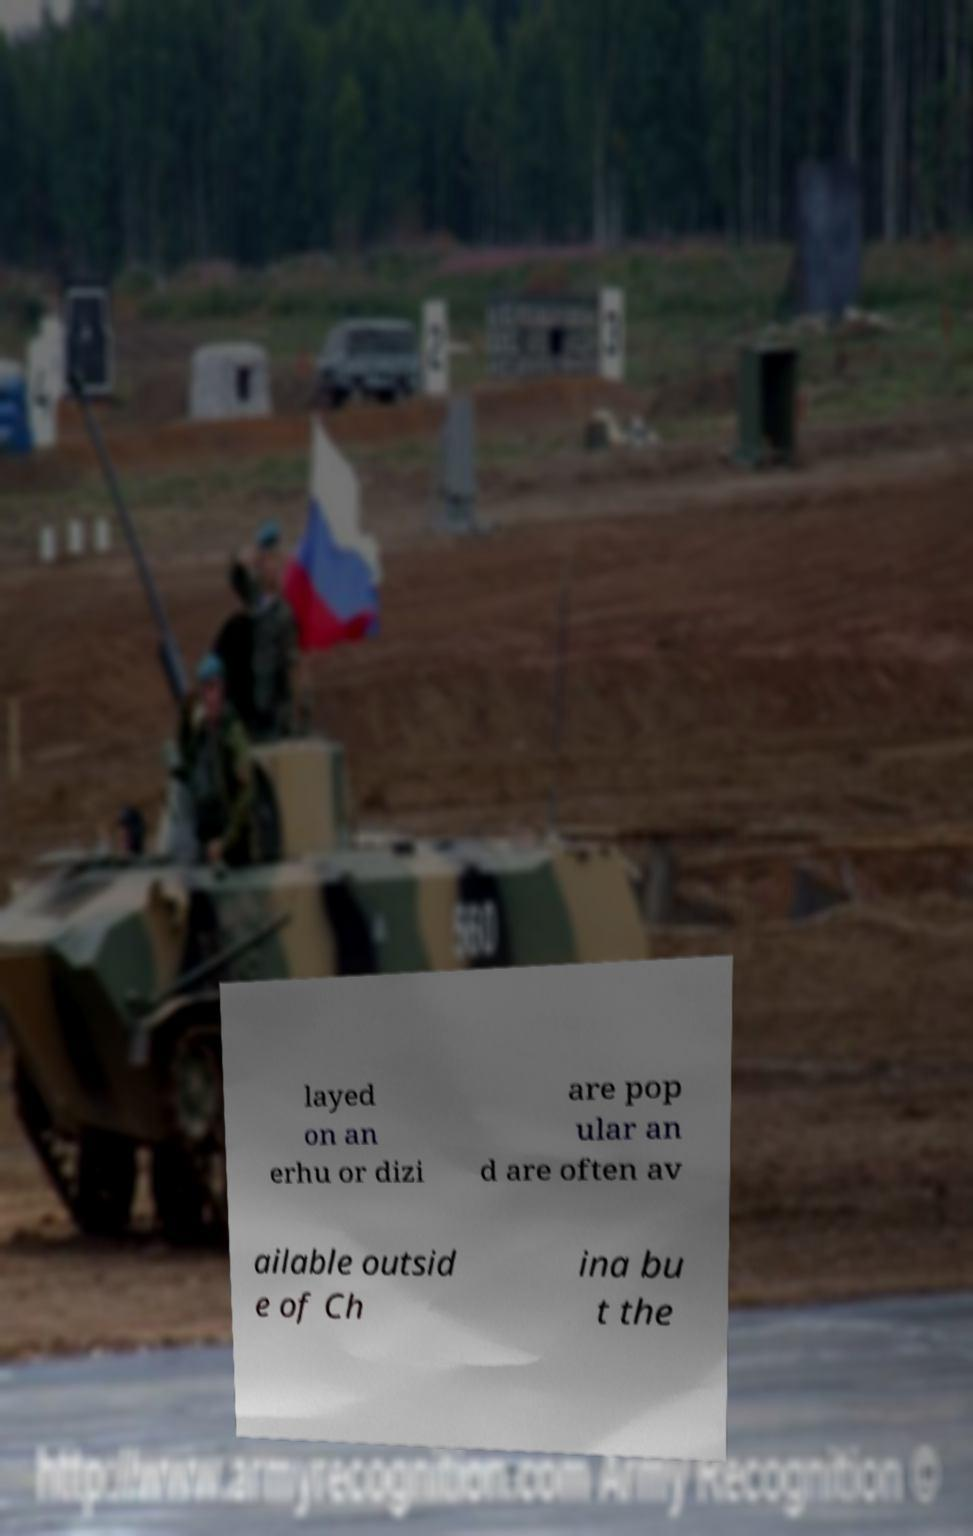Could you assist in decoding the text presented in this image and type it out clearly? layed on an erhu or dizi are pop ular an d are often av ailable outsid e of Ch ina bu t the 